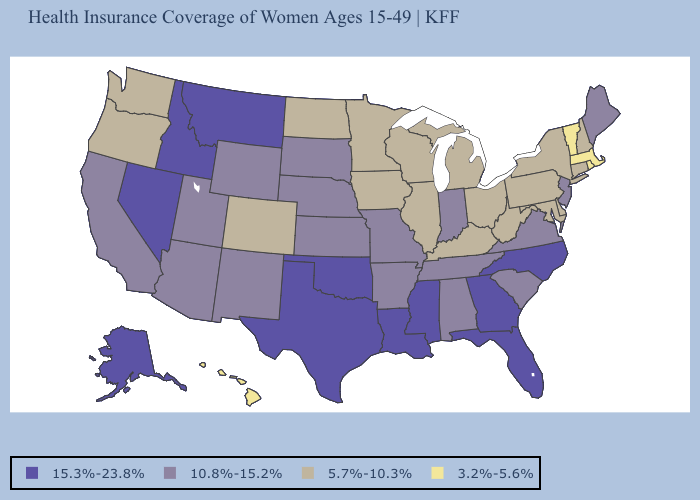What is the value of Mississippi?
Concise answer only. 15.3%-23.8%. Does Georgia have the highest value in the South?
Answer briefly. Yes. What is the value of Tennessee?
Keep it brief. 10.8%-15.2%. Does Vermont have the lowest value in the USA?
Keep it brief. Yes. What is the value of New Mexico?
Keep it brief. 10.8%-15.2%. Does Arkansas have a lower value than Oregon?
Be succinct. No. Does South Dakota have a lower value than Virginia?
Give a very brief answer. No. Which states have the lowest value in the MidWest?
Write a very short answer. Illinois, Iowa, Michigan, Minnesota, North Dakota, Ohio, Wisconsin. Does New Mexico have a lower value than Montana?
Be succinct. Yes. Name the states that have a value in the range 15.3%-23.8%?
Quick response, please. Alaska, Florida, Georgia, Idaho, Louisiana, Mississippi, Montana, Nevada, North Carolina, Oklahoma, Texas. Name the states that have a value in the range 15.3%-23.8%?
Quick response, please. Alaska, Florida, Georgia, Idaho, Louisiana, Mississippi, Montana, Nevada, North Carolina, Oklahoma, Texas. Does Rhode Island have the lowest value in the USA?
Write a very short answer. Yes. What is the highest value in states that border Maryland?
Quick response, please. 10.8%-15.2%. What is the highest value in states that border Colorado?
Write a very short answer. 15.3%-23.8%. Does Maine have the same value as Utah?
Answer briefly. Yes. 